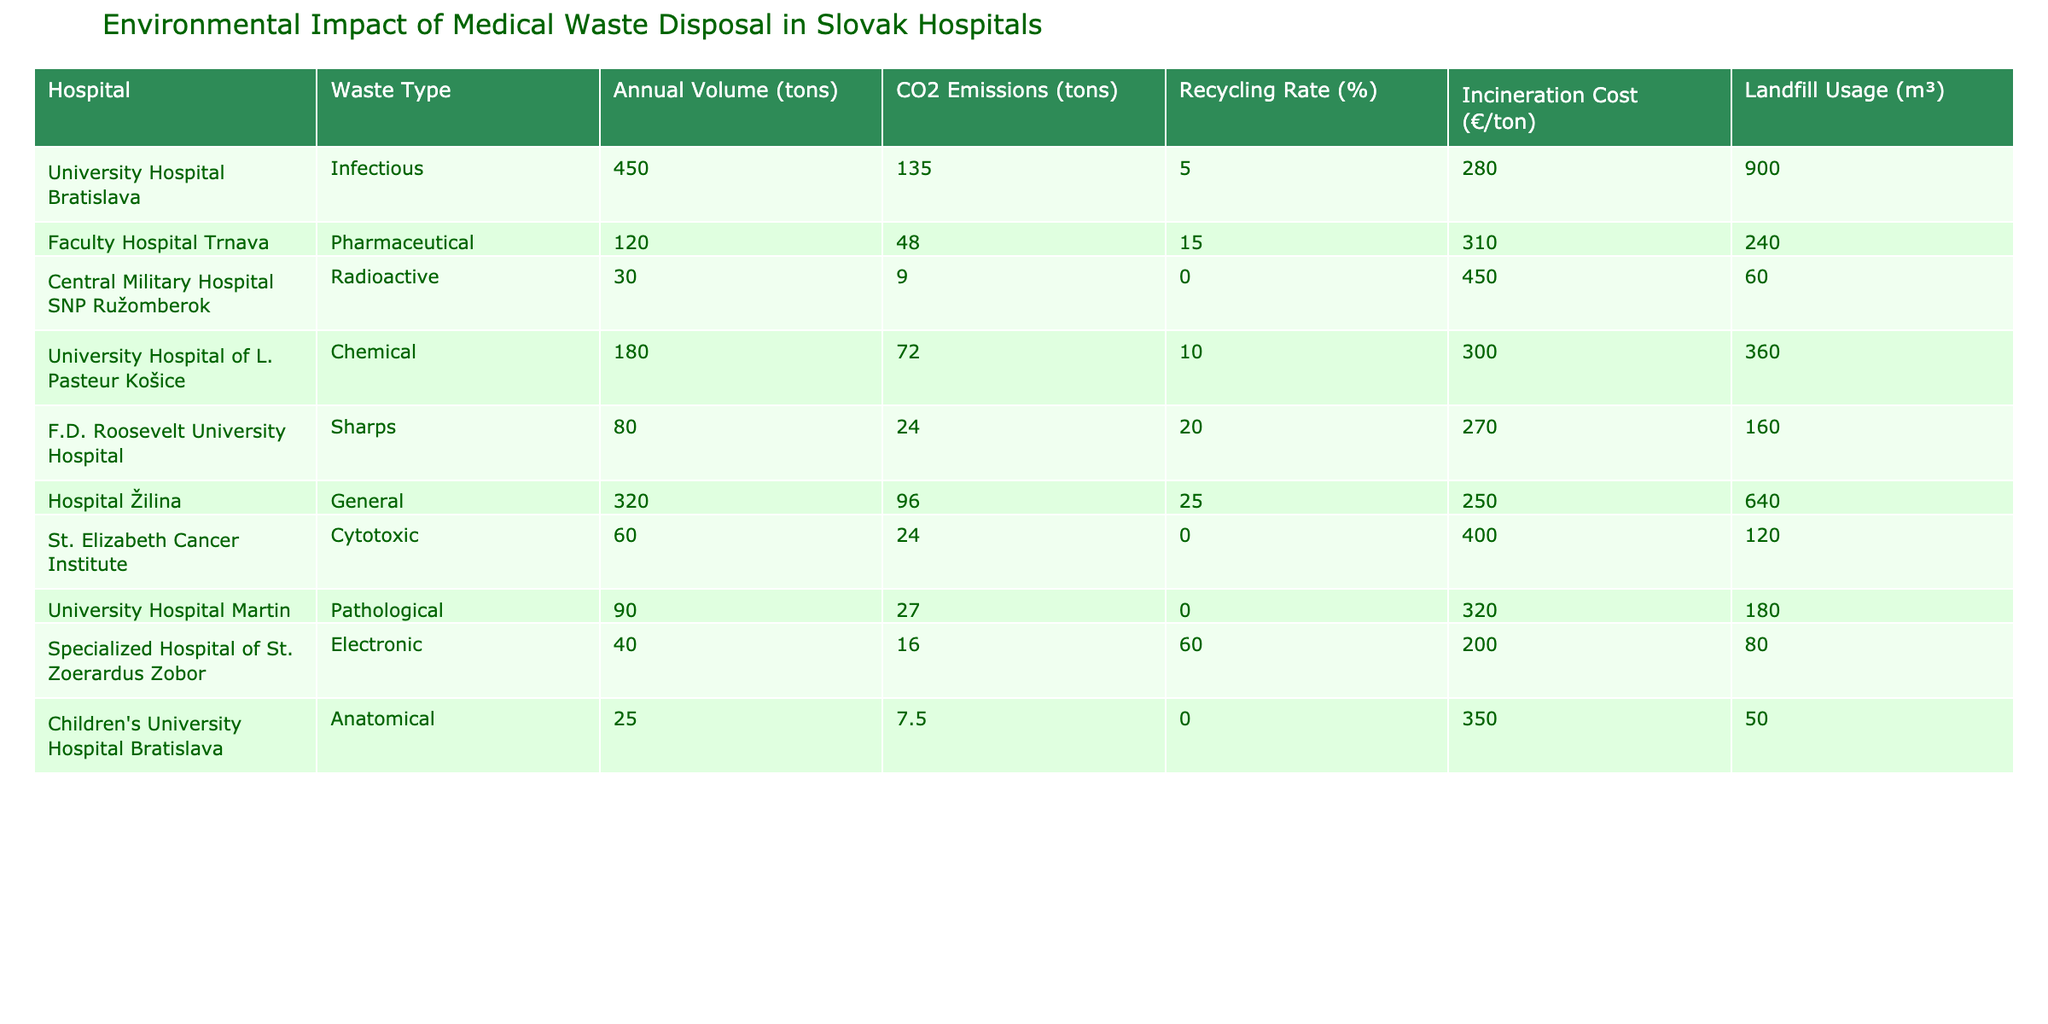What is the total annual volume of infectious waste in Slovak hospitals? The only hospital listed with infectious waste is the University Hospital Bratislava, which has an annual volume of 450 tons. Since it is the only figure provided for infectious waste, it directly represents the total.
Answer: 450 tons Which hospital has the highest recycling rate? By examining the recycling rates across all hospitals, Specialized Hospital of St. Zoerardus Zobor has the highest recycling rate at 60%.
Answer: 60% What is the total landfill usage for all hospitals combined? Summing the landfill usage from all hospitals gives: 900 + 240 + 60 + 360 + 160 + 640 + 120 + 180 + 50 = 2,710 m³.
Answer: 2710 m³ Is the CO2 emissions from the Faculty Hospital Trnava higher than that from the Central Military Hospital SNP Ružomberok? Faculty Hospital Trnava has 48 tons of CO2 emissions, while Central Military Hospital SNP Ružomberok has 9 tons. Since 48 is greater than 9, the statement is true.
Answer: Yes What is the average annual volume of chemical and pharmaceutical waste in Slovak hospitals? The annual volume for chemicals is 180 tons from the University Hospital of L. Pasteur Košice, and for pharmaceuticals, it is 120 tons from Faculty Hospital Trnava. The total volume is (180 + 120) = 300 tons, and dividing by 2 gives an average of 150 tons.
Answer: 150 tons Which type of medical waste contributes the least to CO2 emissions? The type that contributes the least is the Radioactive waste from Central Military Hospital SNP Ružomberok, which has 9 tons of CO2 emissions, the lowest among all waste types.
Answer: Radioactive How much CO2 is emitted from the disposal of general waste compared to infectious waste? Hospital Žilina, which has general waste, emits 96 tons of CO2, while the University Hospital Bratislava with infectious waste emits 135 tons. The difference is 135 - 96 = 39 tons, showing infectious waste contributes more.
Answer: 39 tons What is the total incineration cost for pathological waste and anatomical waste combined? The incineration cost for pathological waste from University Hospital Martin is 320 €/ton, and for anatomical waste from Children's University Hospital Bratislava, it is 350 €/ton. Since both hospitals contribute 90 tons (total from both), 320 * 90 + 350 * 25 = 28,800 + 8,750 = 37,550 € in total.
Answer: 37,550 € Which hospital has the lowest annual volume of medical waste? Children's University Hospital Bratislava has the lowest annual volume of anatomical waste at 25 tons.
Answer: 25 tons Are there any hospitals that rely solely on incineration for disposing of radioactive or cytotoxic waste? Looking at the data, Central Military Hospital SNP Ružomberok has a 0% recycling rate for radioactive waste, indicating it relies entirely on incineration for disposal. Similarly, St. Elizabeth Cancer Institute has a 0% rate for cytotoxic waste, also indicating reliance on incineration.
Answer: Yes 